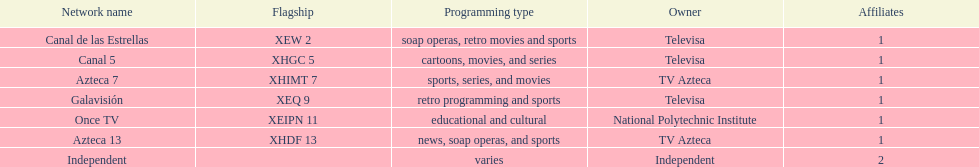Who is the sole network owner mentioned in the chart appearing in a consecutive sequence? Televisa. Could you parse the entire table as a dict? {'header': ['Network name', 'Flagship', 'Programming type', 'Owner', 'Affiliates'], 'rows': [['Canal de las Estrellas', 'XEW 2', 'soap operas, retro movies and sports', 'Televisa', '1'], ['Canal 5', 'XHGC 5', 'cartoons, movies, and series', 'Televisa', '1'], ['Azteca 7', 'XHIMT 7', 'sports, series, and movies', 'TV Azteca', '1'], ['Galavisión', 'XEQ 9', 'retro programming and sports', 'Televisa', '1'], ['Once TV', 'XEIPN 11', 'educational and cultural', 'National Polytechnic Institute', '1'], ['Azteca 13', 'XHDF 13', 'news, soap operas, and sports', 'TV Azteca', '1'], ['Independent', '', 'varies', 'Independent', '2']]} 